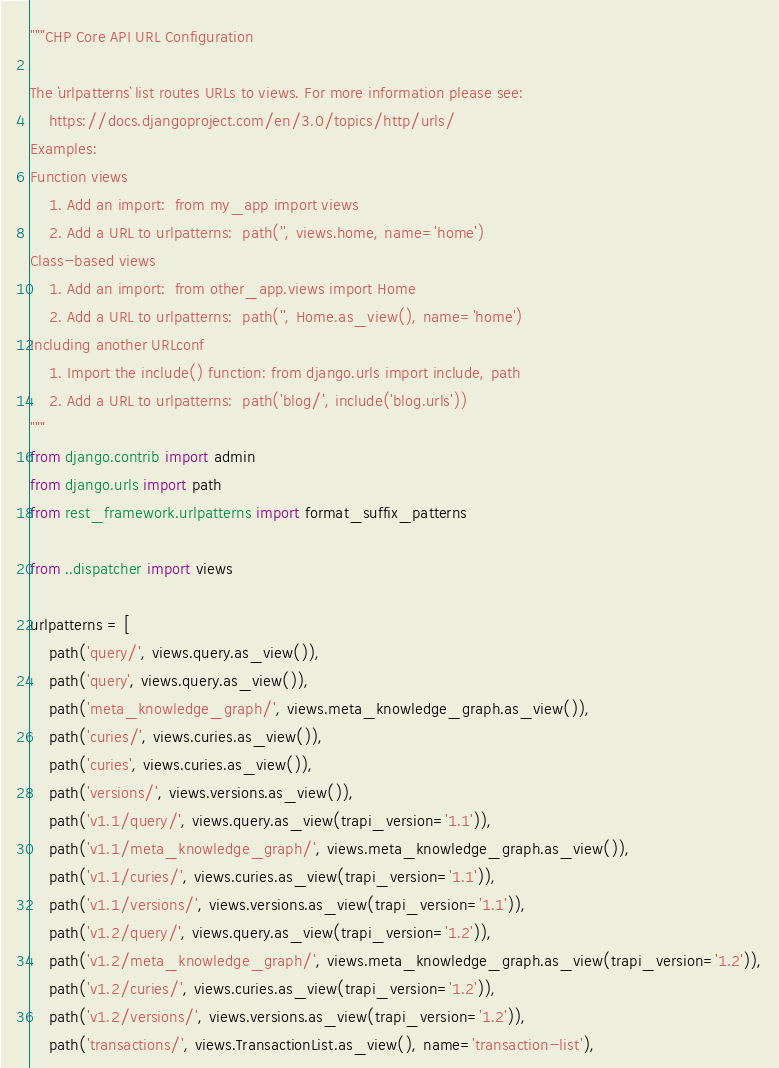<code> <loc_0><loc_0><loc_500><loc_500><_Python_>"""CHP Core API URL Configuration

The `urlpatterns` list routes URLs to views. For more information please see:
    https://docs.djangoproject.com/en/3.0/topics/http/urls/
Examples:
Function views
    1. Add an import:  from my_app import views
    2. Add a URL to urlpatterns:  path('', views.home, name='home')
Class-based views
    1. Add an import:  from other_app.views import Home
    2. Add a URL to urlpatterns:  path('', Home.as_view(), name='home')
Including another URLconf
    1. Import the include() function: from django.urls import include, path
    2. Add a URL to urlpatterns:  path('blog/', include('blog.urls'))
"""
from django.contrib import admin
from django.urls import path
from rest_framework.urlpatterns import format_suffix_patterns

from ..dispatcher import views

urlpatterns = [
    path('query/', views.query.as_view()),
    path('query', views.query.as_view()),
    path('meta_knowledge_graph/', views.meta_knowledge_graph.as_view()),
    path('curies/', views.curies.as_view()),
    path('curies', views.curies.as_view()),
    path('versions/', views.versions.as_view()),
    path('v1.1/query/', views.query.as_view(trapi_version='1.1')),
    path('v1.1/meta_knowledge_graph/', views.meta_knowledge_graph.as_view()),
    path('v1.1/curies/', views.curies.as_view(trapi_version='1.1')),
    path('v1.1/versions/', views.versions.as_view(trapi_version='1.1')),
    path('v1.2/query/', views.query.as_view(trapi_version='1.2')),
    path('v1.2/meta_knowledge_graph/', views.meta_knowledge_graph.as_view(trapi_version='1.2')),
    path('v1.2/curies/', views.curies.as_view(trapi_version='1.2')),
    path('v1.2/versions/', views.versions.as_view(trapi_version='1.2')),
    path('transactions/', views.TransactionList.as_view(), name='transaction-list'),</code> 